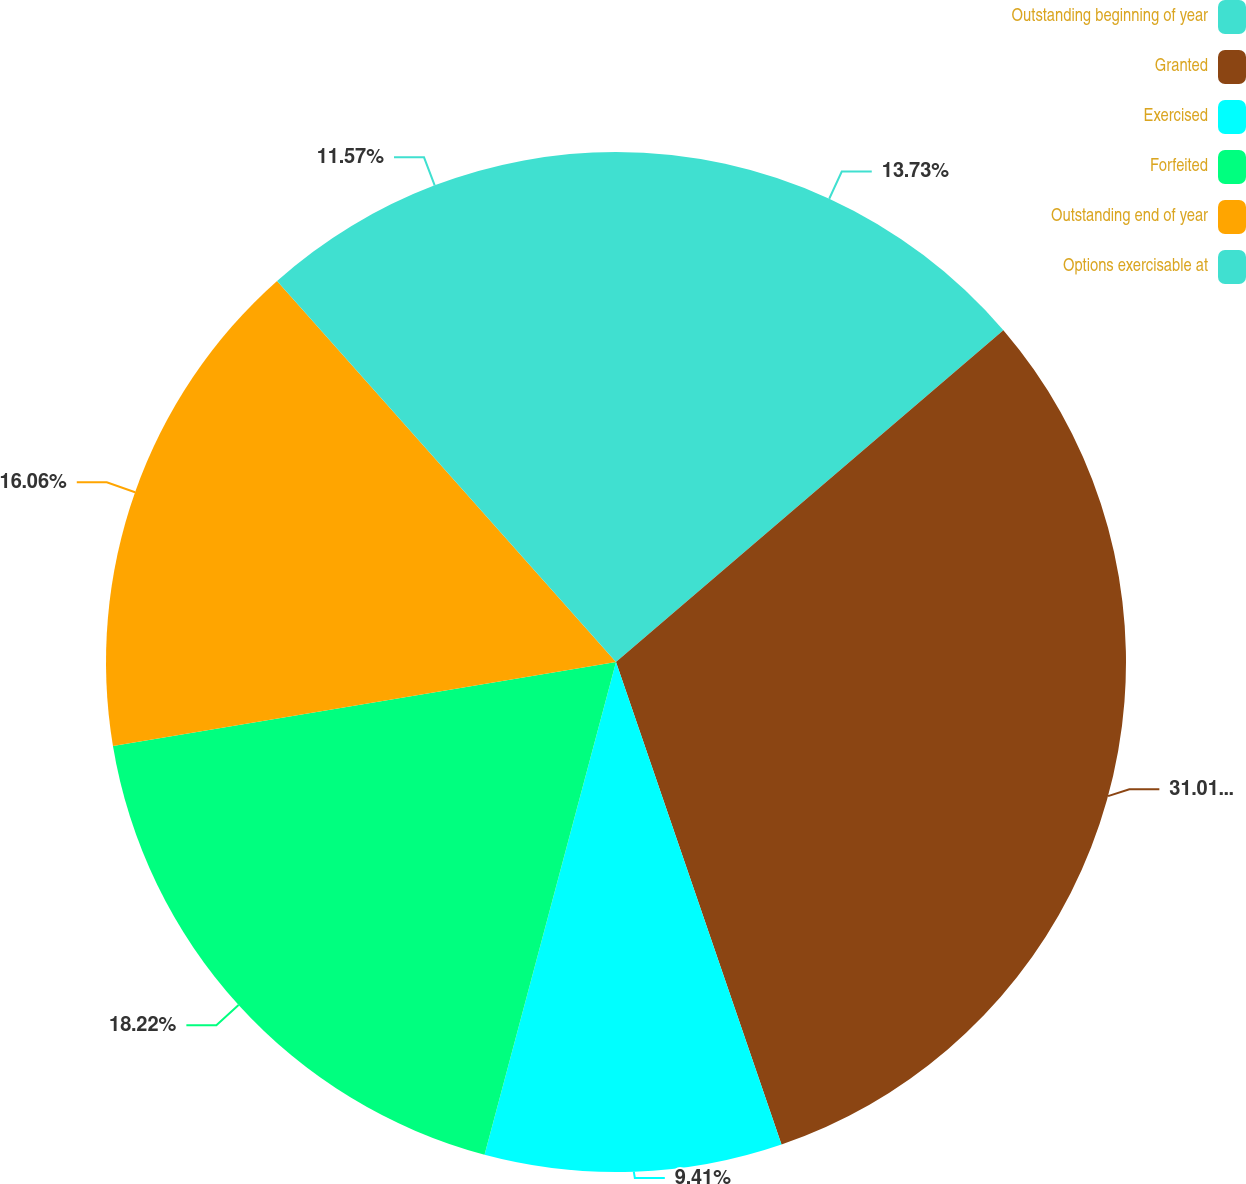Convert chart. <chart><loc_0><loc_0><loc_500><loc_500><pie_chart><fcel>Outstanding beginning of year<fcel>Granted<fcel>Exercised<fcel>Forfeited<fcel>Outstanding end of year<fcel>Options exercisable at<nl><fcel>13.73%<fcel>31.01%<fcel>9.41%<fcel>18.22%<fcel>16.06%<fcel>11.57%<nl></chart> 